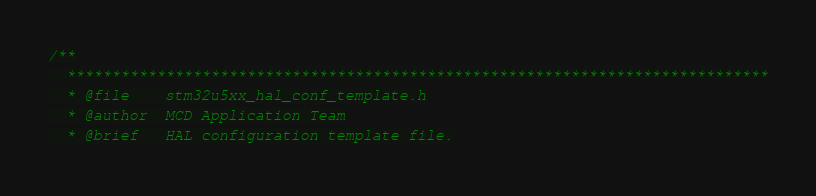Convert code to text. <code><loc_0><loc_0><loc_500><loc_500><_C_>/**
  ******************************************************************************
  * @file    stm32u5xx_hal_conf_template.h
  * @author  MCD Application Team
  * @brief   HAL configuration template file.</code> 